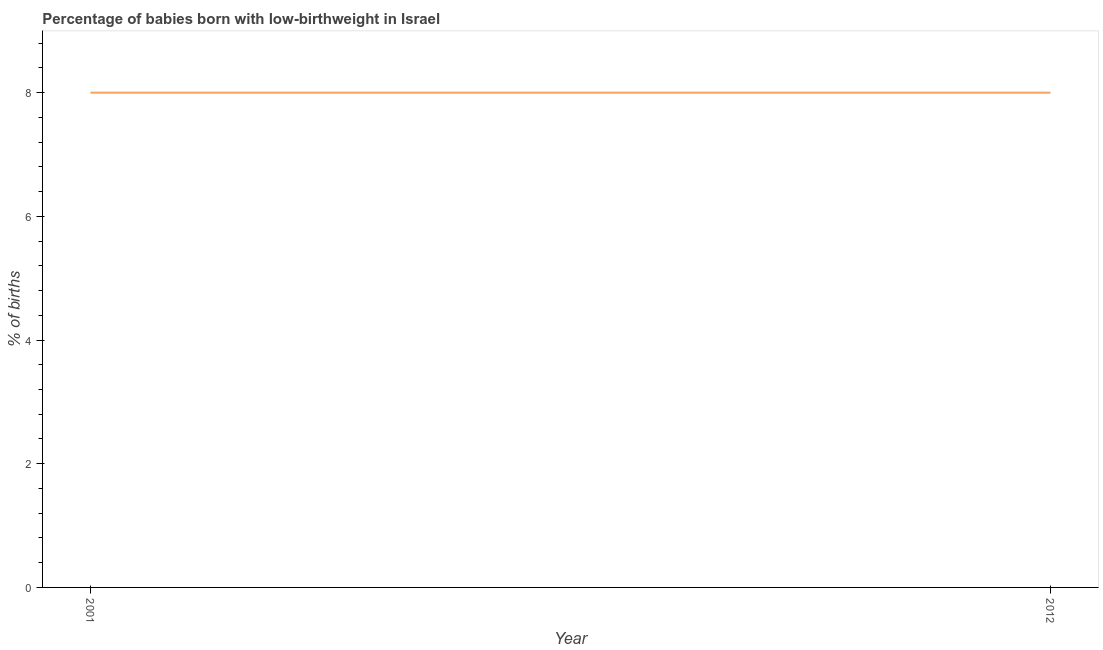What is the percentage of babies who were born with low-birthweight in 2012?
Ensure brevity in your answer.  8. Across all years, what is the maximum percentage of babies who were born with low-birthweight?
Ensure brevity in your answer.  8. Across all years, what is the minimum percentage of babies who were born with low-birthweight?
Provide a succinct answer. 8. In which year was the percentage of babies who were born with low-birthweight maximum?
Provide a short and direct response. 2001. In which year was the percentage of babies who were born with low-birthweight minimum?
Offer a very short reply. 2001. What is the sum of the percentage of babies who were born with low-birthweight?
Your answer should be compact. 16. What is the difference between the percentage of babies who were born with low-birthweight in 2001 and 2012?
Give a very brief answer. 0. What is the average percentage of babies who were born with low-birthweight per year?
Give a very brief answer. 8. What is the ratio of the percentage of babies who were born with low-birthweight in 2001 to that in 2012?
Make the answer very short. 1. Is the percentage of babies who were born with low-birthweight in 2001 less than that in 2012?
Provide a succinct answer. No. In how many years, is the percentage of babies who were born with low-birthweight greater than the average percentage of babies who were born with low-birthweight taken over all years?
Provide a succinct answer. 0. How many years are there in the graph?
Ensure brevity in your answer.  2. What is the difference between two consecutive major ticks on the Y-axis?
Ensure brevity in your answer.  2. Does the graph contain any zero values?
Your answer should be very brief. No. What is the title of the graph?
Your answer should be very brief. Percentage of babies born with low-birthweight in Israel. What is the label or title of the X-axis?
Offer a very short reply. Year. What is the label or title of the Y-axis?
Provide a succinct answer. % of births. What is the % of births of 2001?
Ensure brevity in your answer.  8. What is the % of births in 2012?
Your response must be concise. 8. What is the difference between the % of births in 2001 and 2012?
Your response must be concise. 0. What is the ratio of the % of births in 2001 to that in 2012?
Your answer should be compact. 1. 